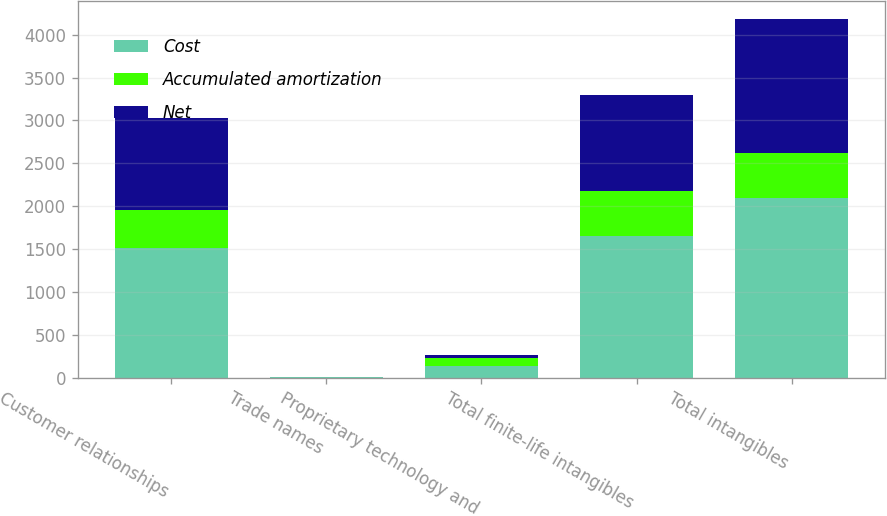Convert chart. <chart><loc_0><loc_0><loc_500><loc_500><stacked_bar_chart><ecel><fcel>Customer relationships<fcel>Trade names<fcel>Proprietary technology and<fcel>Total finite-life intangibles<fcel>Total intangibles<nl><fcel>Cost<fcel>1513.9<fcel>1.5<fcel>131.9<fcel>1647.3<fcel>2091.5<nl><fcel>Accumulated amortization<fcel>437.5<fcel>1.4<fcel>94.2<fcel>533.1<fcel>533.1<nl><fcel>Net<fcel>1076.4<fcel>0.1<fcel>37.7<fcel>1114.2<fcel>1558.4<nl></chart> 